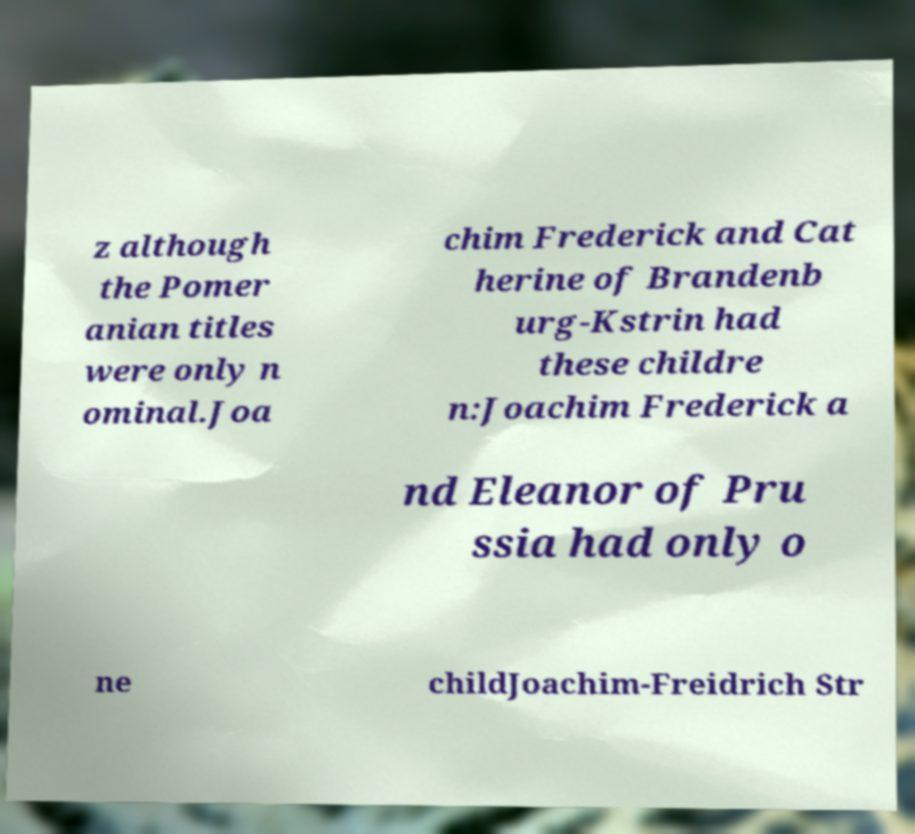Can you accurately transcribe the text from the provided image for me? z although the Pomer anian titles were only n ominal.Joa chim Frederick and Cat herine of Brandenb urg-Kstrin had these childre n:Joachim Frederick a nd Eleanor of Pru ssia had only o ne childJoachim-Freidrich Str 